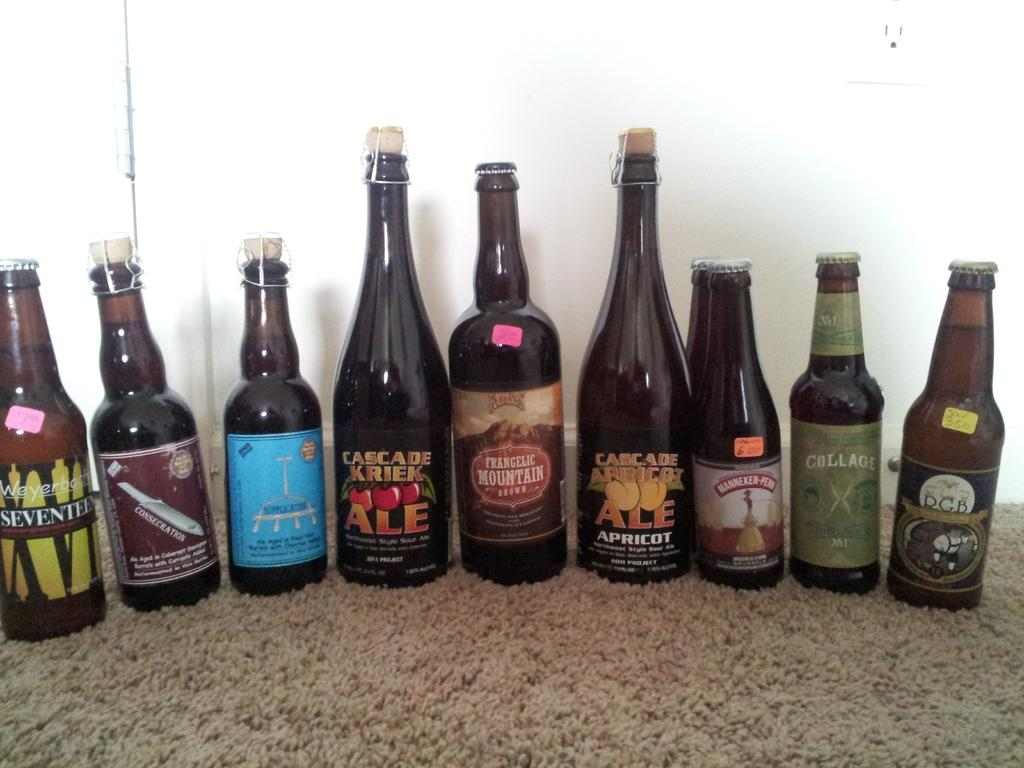<image>
Give a short and clear explanation of the subsequent image. The bottle with the cherries on it is called Cascade Creek Ale 